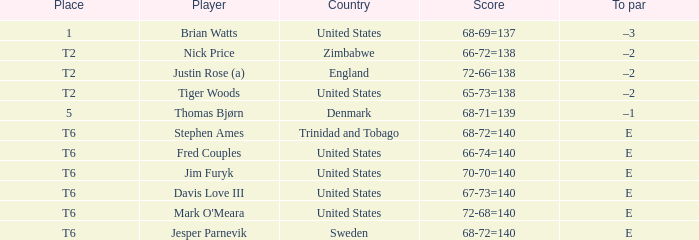With a score of 68-69=137, what was the to par for the respective player? –3. 